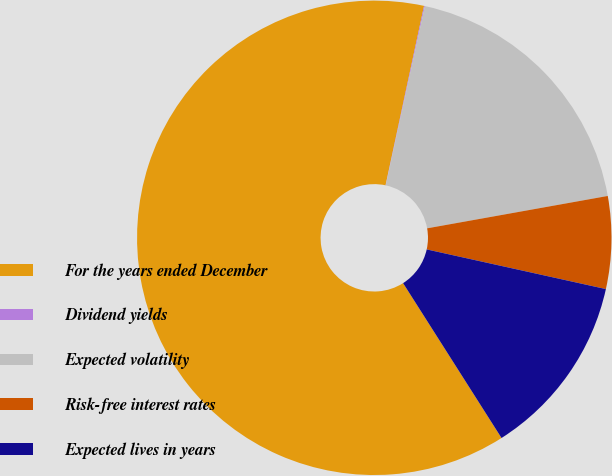Convert chart to OTSL. <chart><loc_0><loc_0><loc_500><loc_500><pie_chart><fcel>For the years ended December<fcel>Dividend yields<fcel>Expected volatility<fcel>Risk-free interest rates<fcel>Expected lives in years<nl><fcel>62.37%<fcel>0.06%<fcel>18.75%<fcel>6.29%<fcel>12.52%<nl></chart> 